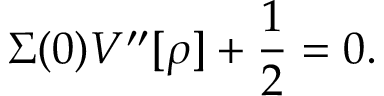<formula> <loc_0><loc_0><loc_500><loc_500>\Sigma ( 0 ) V ^ { \prime \prime } [ \rho ] + \frac { 1 } { 2 } = 0 .</formula> 